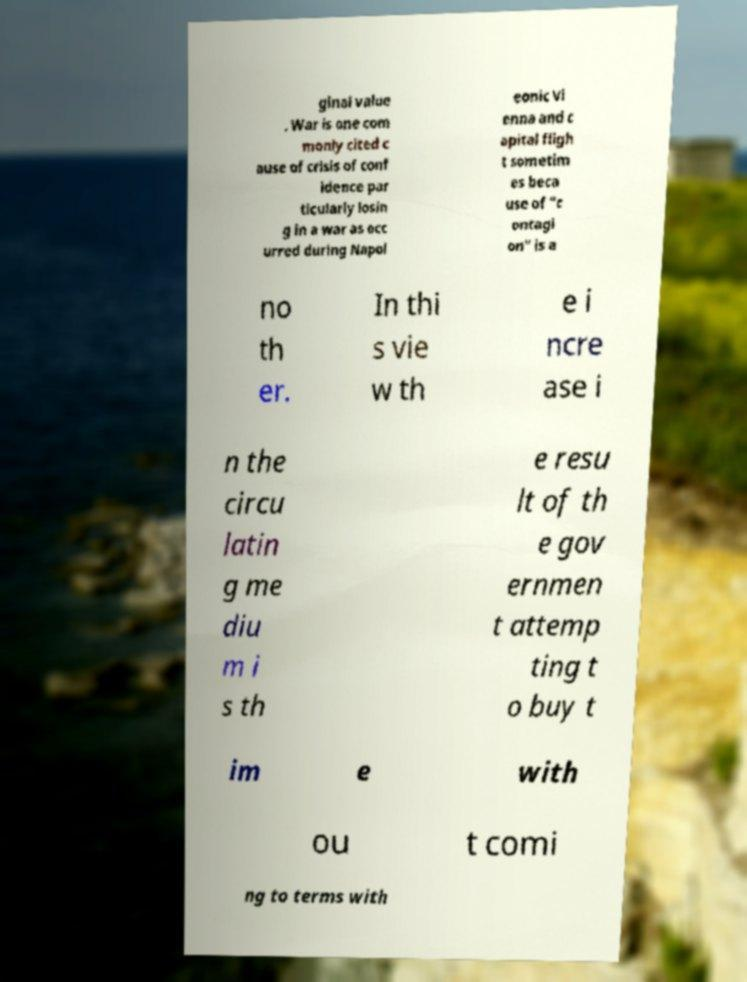Can you accurately transcribe the text from the provided image for me? ginal value . War is one com monly cited c ause of crisis of conf idence par ticularly losin g in a war as occ urred during Napol eonic Vi enna and c apital fligh t sometim es beca use of "c ontagi on" is a no th er. In thi s vie w th e i ncre ase i n the circu latin g me diu m i s th e resu lt of th e gov ernmen t attemp ting t o buy t im e with ou t comi ng to terms with 